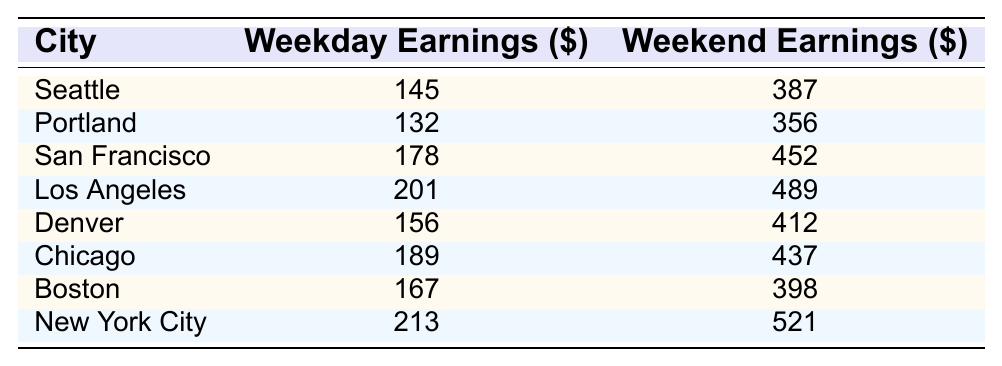What city has the highest weekend earnings? Looking at the weekend earnings column, New York City has the highest value at 521.
Answer: New York City What is the weekday earnings for San Francisco? The table shows that the weekday earnings for San Francisco is 178.
Answer: 178 Which city has earnings that are closest on weekdays and weekends? By examining the differences, Chicago has weekday earnings of 189 and weekend earnings of 437, making the difference 248, which is the smallest compared to other cities.
Answer: Chicago What is the difference between weekday and weekend earnings in Seattle? Subtract the weekday earnings (145) from the weekend earnings (387) to find the difference: 387 - 145 = 242.
Answer: 242 Which city earns more on weekends than on weekdays by a margin of at least 300? Analyzing each city's data, Los Angeles earns 489 on weekends and 201 on weekdays, resulting in a margin of 288, which does not meet the criteria. However, New York City's difference is 521 - 213 = 308, which qualifies.
Answer: New York City What is the average weekend earning across all listed cities? First, sum the weekend earnings: 387 + 356 + 452 + 489 + 412 + 437 + 398 + 521 = 3432. Then divide by the number of cities (8), resulting in an average of 3432 / 8 = 429.
Answer: 429 In which city did weekend earnings exceed weekday earnings by the smallest amount? Calculate the differences for each city: Seattle (242), Portland (224), San Francisco (274), Los Angeles (288), Denver (256), Chicago (248), Boston (231), New York City (308). The smallest difference is in Portland with 224.
Answer: Portland Is it true that all cities have higher weekend earnings than weekday earnings? Examining the values, every city shows that weekend earnings are greater than weekday earnings. Thus, the statement is true.
Answer: Yes What is the total earning from weekday sales for all cities combined? Adding all weekday earnings: 145 + 132 + 178 + 201 + 156 + 189 + 167 + 213 = 1,281.
Answer: 1281 Which city has the highest earnings in both categories? New York City has the highest weekday earnings at 213 and weekend earnings at 521.
Answer: New York City 